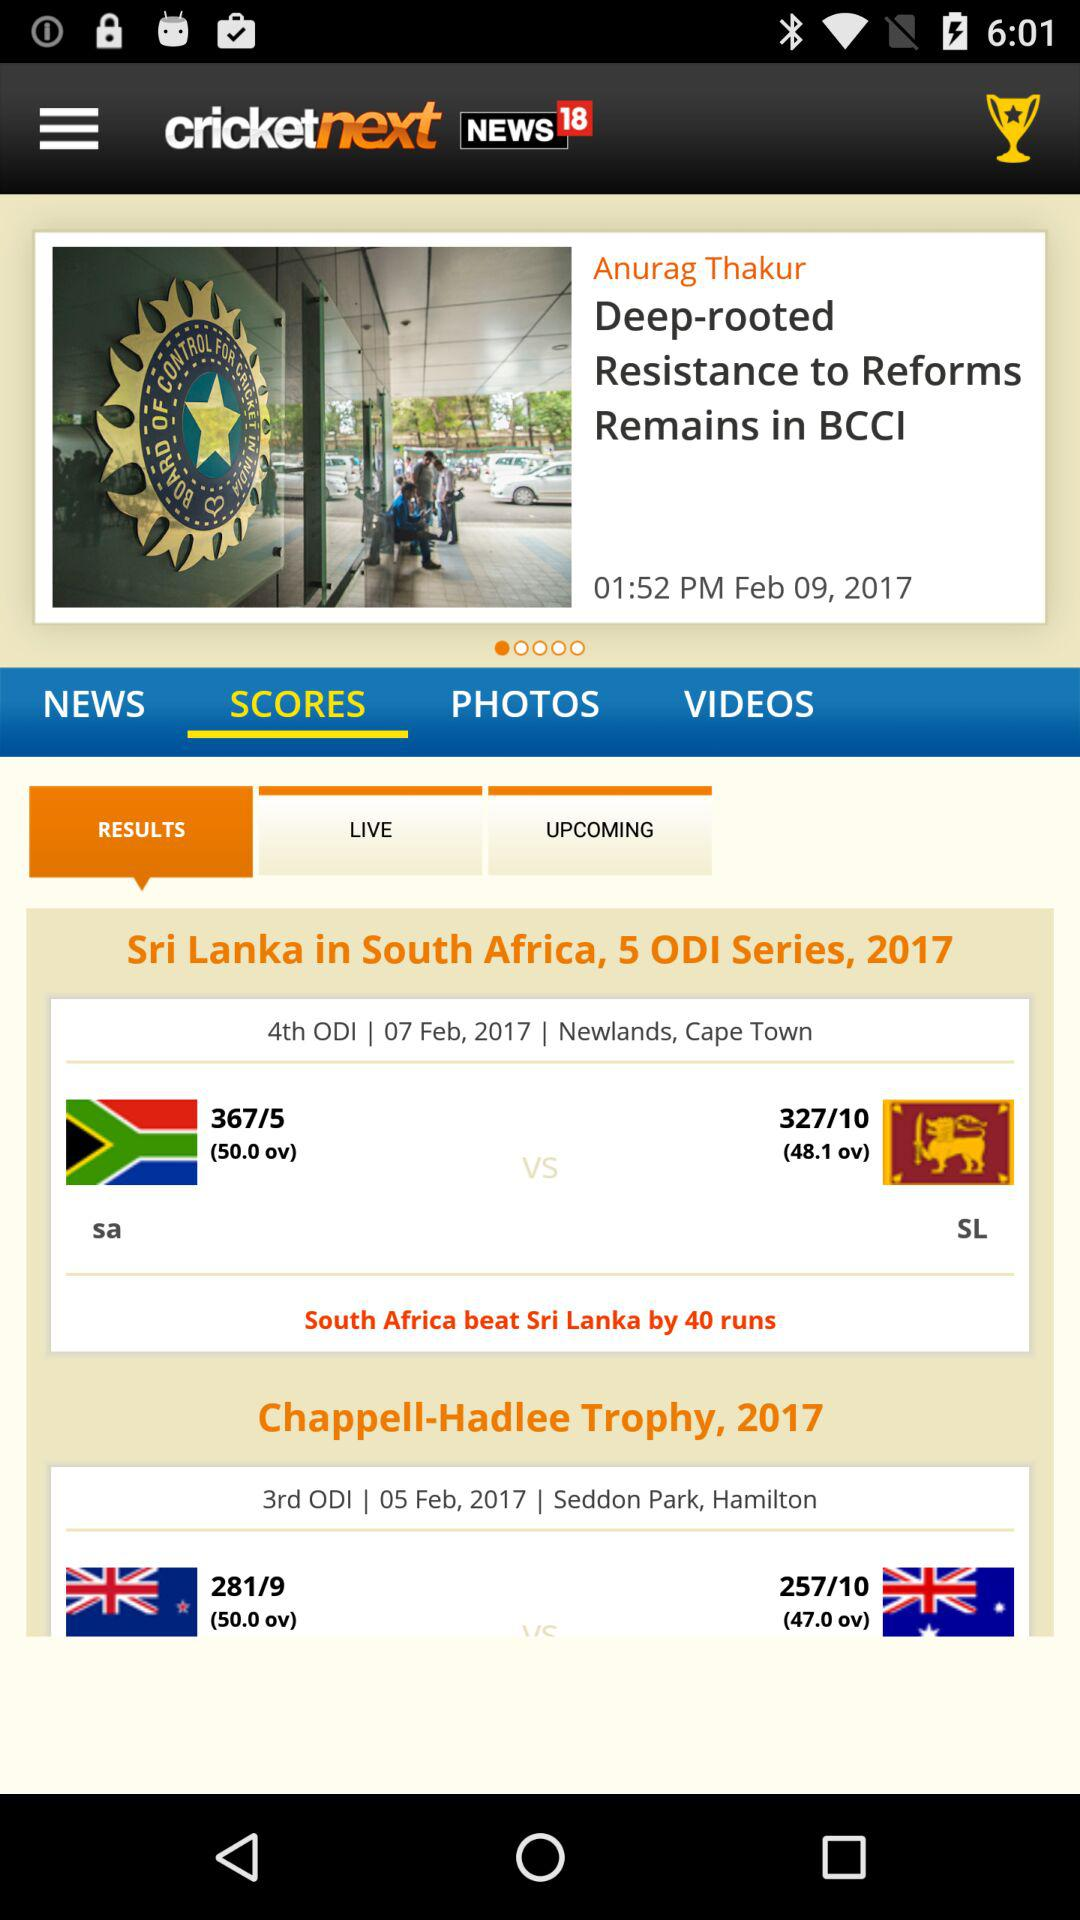Where was the 4th ODI held? The 4th ODI was held in Newlands, Cape Town. 